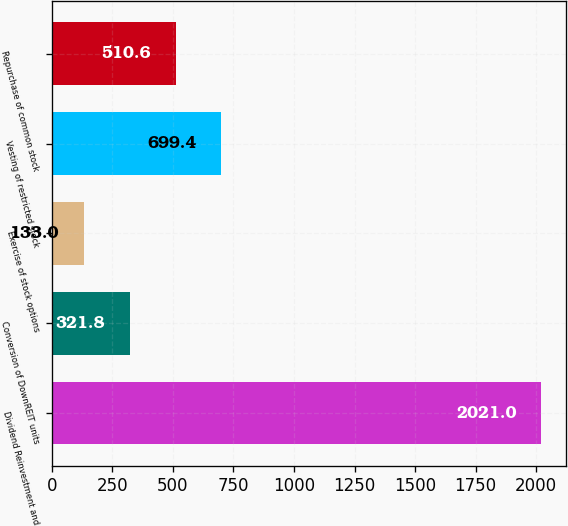Convert chart to OTSL. <chart><loc_0><loc_0><loc_500><loc_500><bar_chart><fcel>Dividend Reinvestment and<fcel>Conversion of DownREIT units<fcel>Exercise of stock options<fcel>Vesting of restricted stock<fcel>Repurchase of common stock<nl><fcel>2021<fcel>321.8<fcel>133<fcel>699.4<fcel>510.6<nl></chart> 